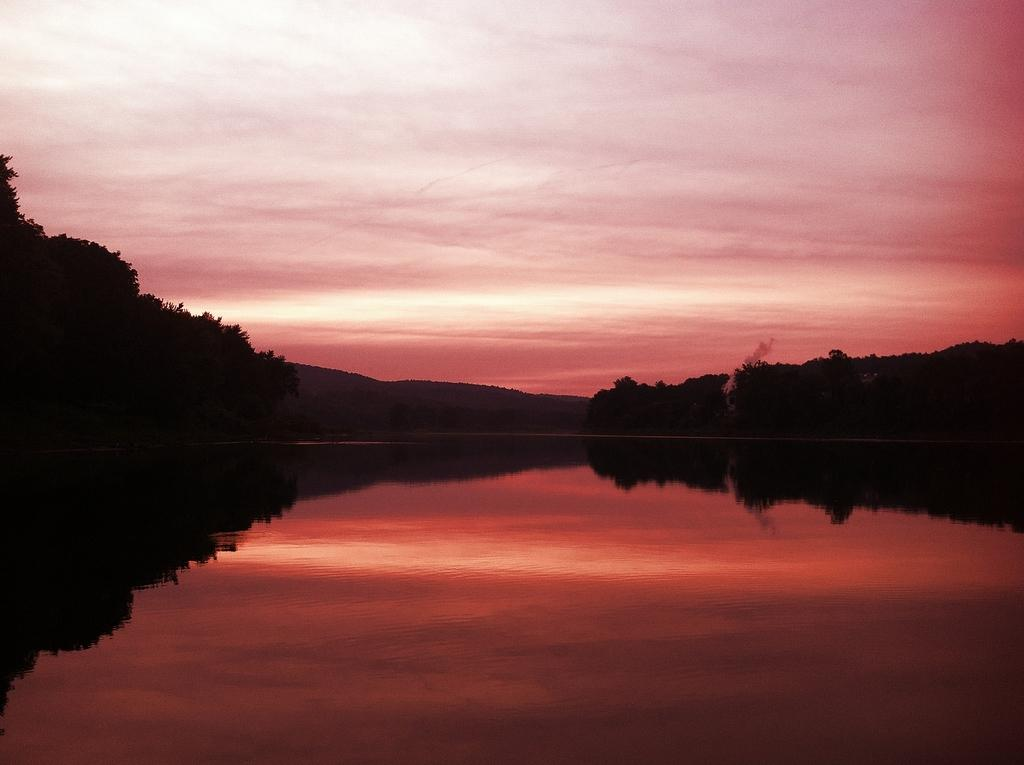What is located in the center of the image? There is water in the center of the image. What type of vegetation can be seen in the image? There are trees in the image. What is the condition of the sky in the image? The sky is cloudy in the image. What color of paint is being used on the top of the trees in the image? There is no paint or indication of painting in the image; it features water, trees, and a cloudy sky. 